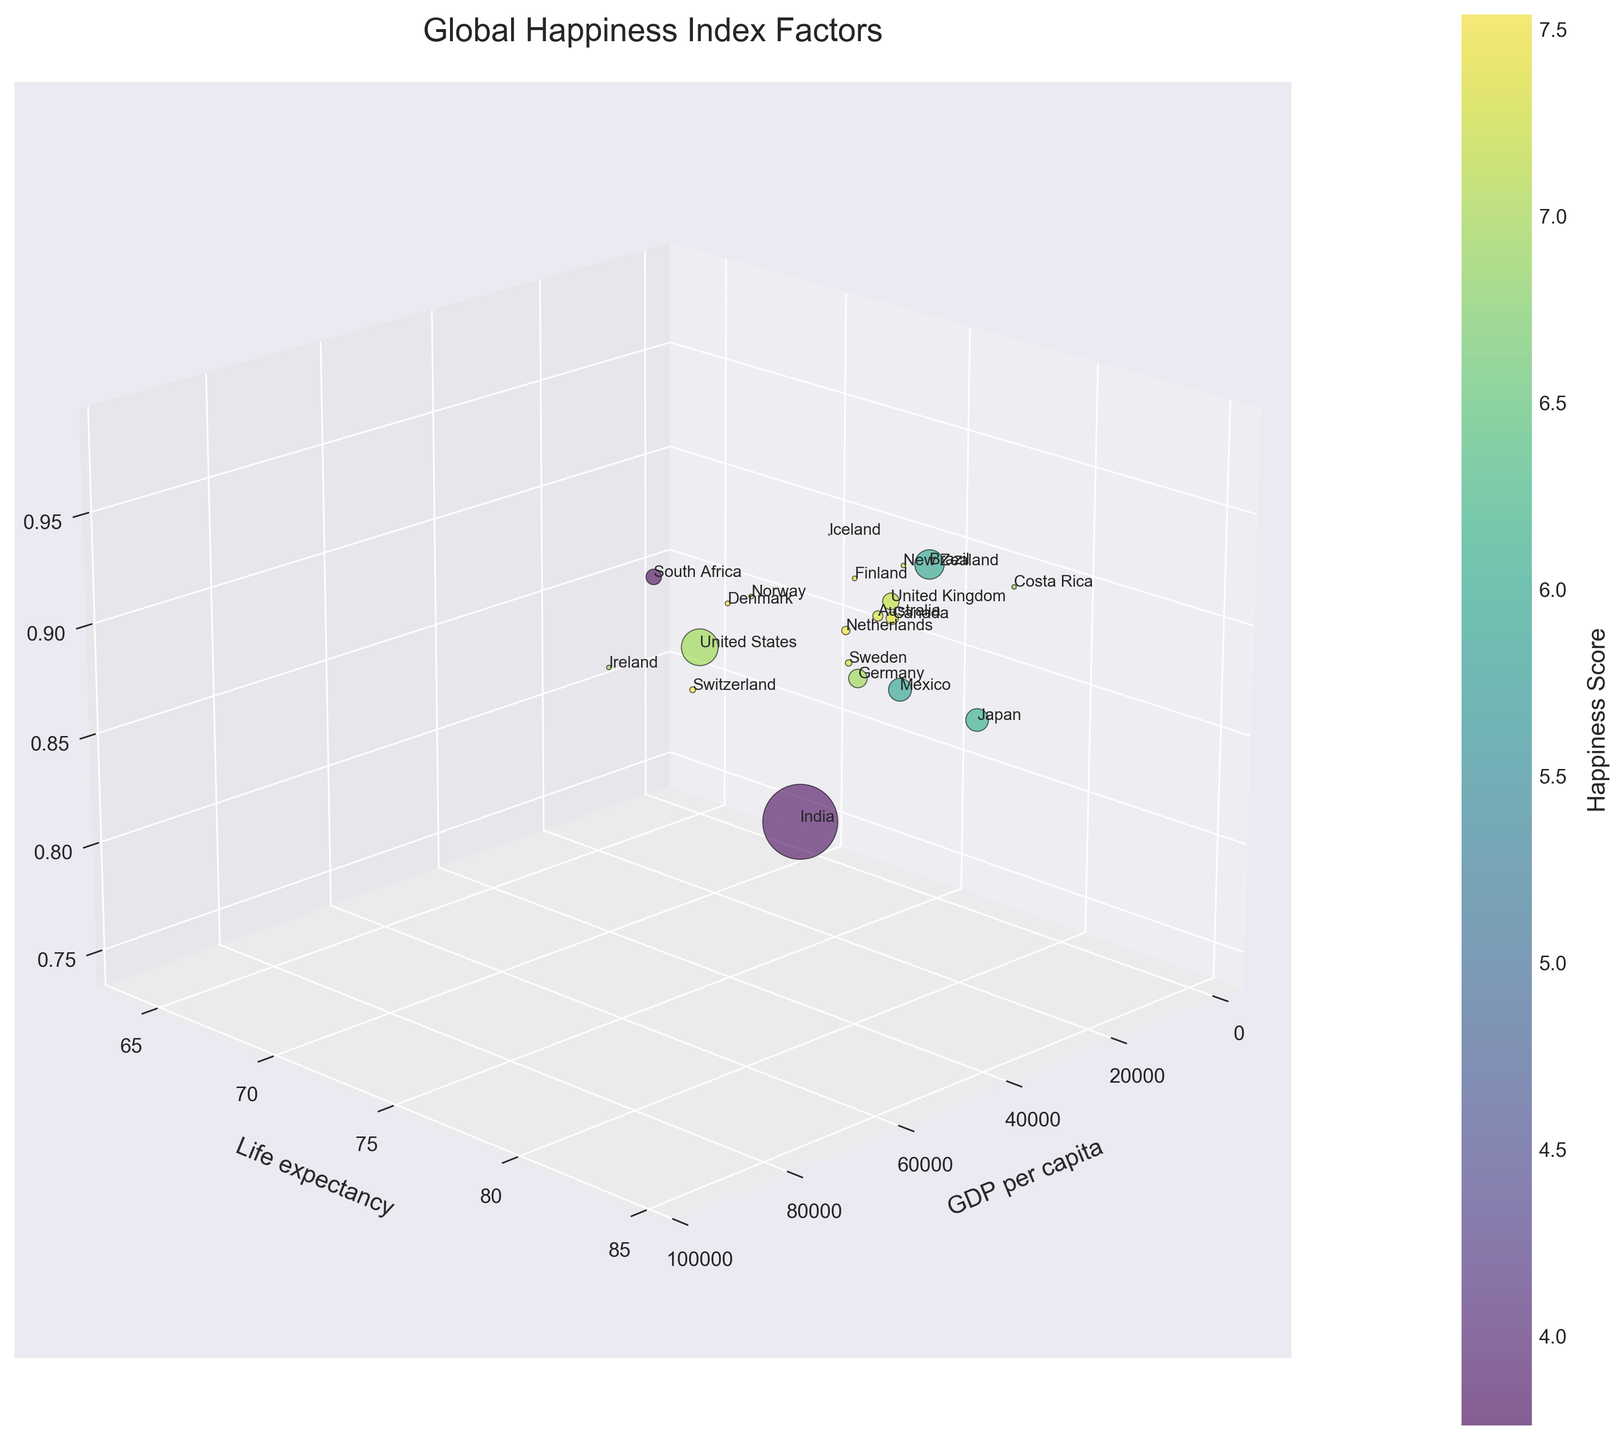What is the title of the chart? The title is displayed at the top of the 3D bubble chart and helps to understand the overall subject of the visualization.
Answer: Global Happiness Index Factors How is the happiness score visually represented on the chart? Colors represent the happiness scores, with a color bar on the right side indicating the range of happiness scores from low to high.
Answer: Colors Which axis represents GDP per capita? The horizontal X-axis at the bottom of the 3D chart is labeled "GDP per capita."
Answer: X-axis Which country has the highest life expectancy? By looking at the vertical Y-axis (Life expectancy) and identifying the bubble situated the highest, we see Japan has the highest life expectancy.
Answer: Japan What size do the bubbles represent? The size of the bubbles represents the population, with larger bubbles indicating larger populations and smaller bubbles indicating smaller populations.
Answer: Population Which country shows a high GDP per capita, high social support, but low happiness score relatively? By examining the bubbles that are high on the GDP per capita and social support axes but low on the color scale for happiness scores, the United States fits this criterion.
Answer: United States Which country has the highest happiness score? By looking at the color bar and identifying the bubble with the brightest color, Norway has the highest happiness score of 7.54.
Answer: Norway Which countries have life expectancy above 82 and GDP per capita above 70,000? By identifying the bubbles located above "82" on the Y-axis and greater than "70,000" on the X-axis while checking their labels, Norway and Switzerland meet this criteria.
Answer: Norway, Switzerland Which country has a lower happiness score and life expectancy but a high social support score? By examining the lower end of the happiness score color range and life expectancy axis (Y) while still relatively high on the social support axis (Z), South Africa fits this description.
Answer: South Africa 